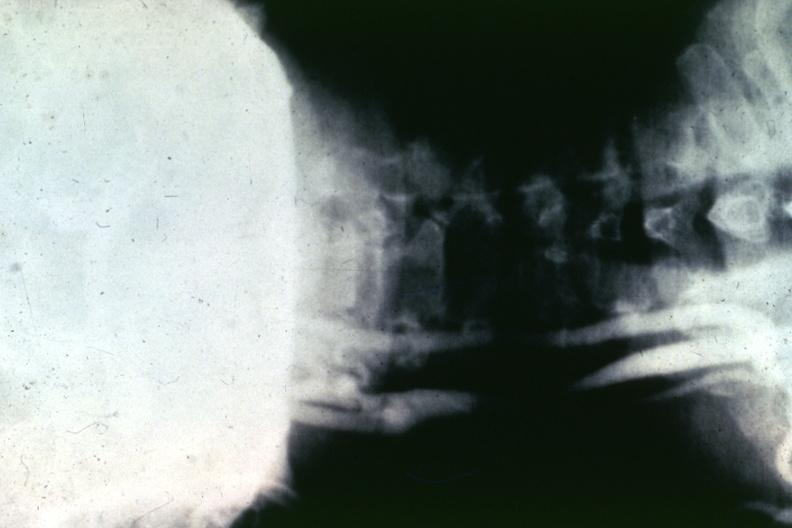what is present?
Answer the question using a single word or phrase. Vasculature 